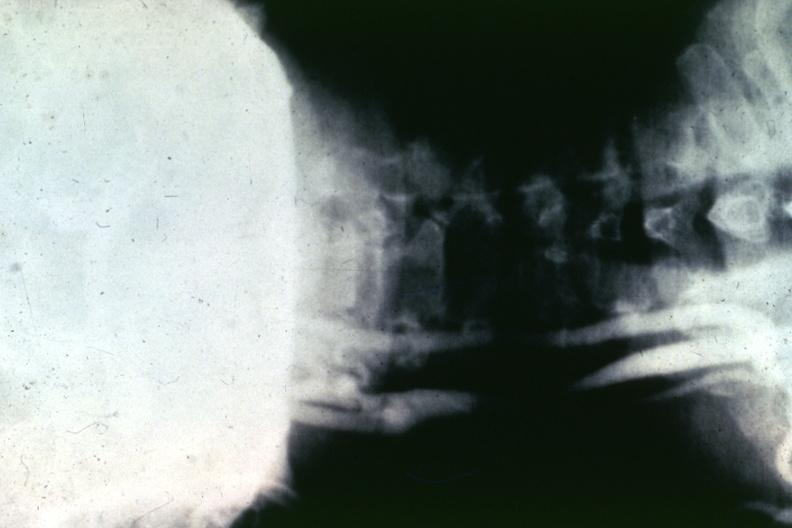what is present?
Answer the question using a single word or phrase. Vasculature 